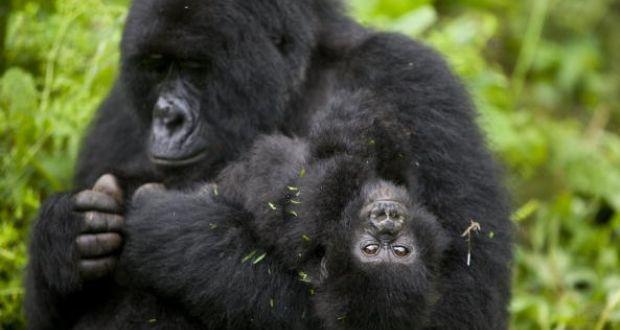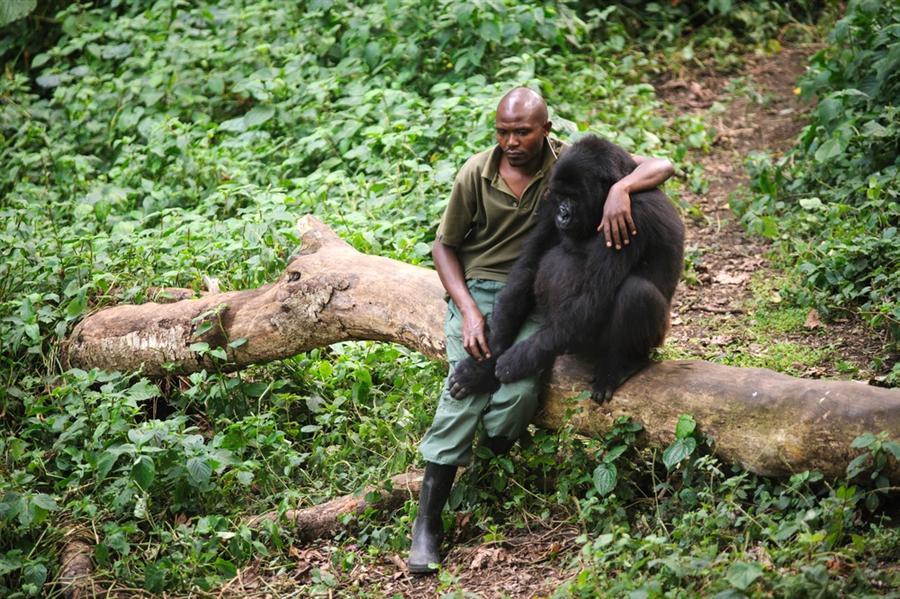The first image is the image on the left, the second image is the image on the right. For the images displayed, is the sentence "There is a person in the image on the right." factually correct? Answer yes or no. Yes. The first image is the image on the left, the second image is the image on the right. Considering the images on both sides, is "One image shows a man in an olive-green shirt interacting with a gorilla." valid? Answer yes or no. Yes. 